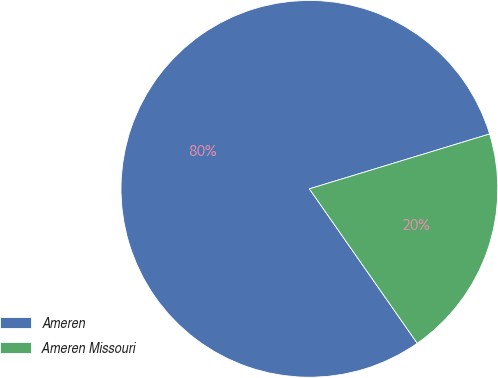Convert chart. <chart><loc_0><loc_0><loc_500><loc_500><pie_chart><fcel>Ameren<fcel>Ameren Missouri<nl><fcel>80.0%<fcel>20.0%<nl></chart> 